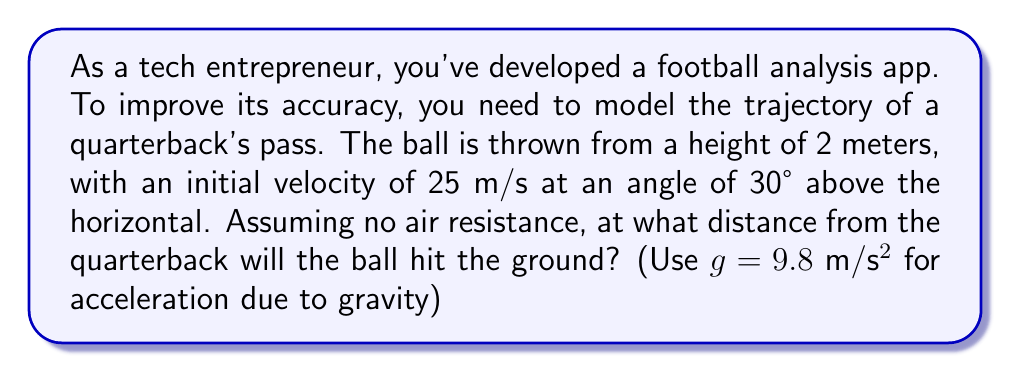Can you answer this question? Let's approach this step-by-step using the parabolic equation for projectile motion:

1) The parabolic equation for the trajectory is:
   $$y = -\frac{1}{2}g(\frac{x}{v_x})^2 + \tan(\theta)x + h$$
   where $y$ is height, $x$ is horizontal distance, $g$ is gravity, $v_x$ is horizontal velocity, $\theta$ is launch angle, and $h$ is initial height.

2) We need to find $v_x$:
   $v_x = v \cos(\theta) = 25 \cos(30°) = 25 * \frac{\sqrt{3}}{2} \approx 21.65$ m/s

3) Now, let's substitute our known values:
   $$y = -\frac{1}{2}(9.8)(\frac{x}{21.65})^2 + \tan(30°)x + 2$$

4) We want to find where the ball hits the ground, so $y = 0$:
   $$0 = -\frac{1}{2}(9.8)(\frac{x}{21.65})^2 + \tan(30°)x + 2$$

5) Simplify:
   $$0 = -0.0105x^2 + 0.577x + 2$$

6) This is a quadratic equation. We can solve it using the quadratic formula:
   $$x = \frac{-b \pm \sqrt{b^2 - 4ac}}{2a}$$
   where $a = -0.0105$, $b = 0.577$, and $c = 2$

7) Solving this:
   $$x \approx 57.7$$ or $$x \approx -3.3$$

8) The negative solution doesn't make physical sense, so we discard it.

Therefore, the ball will hit the ground approximately 57.7 meters from the quarterback.
Answer: 57.7 meters 